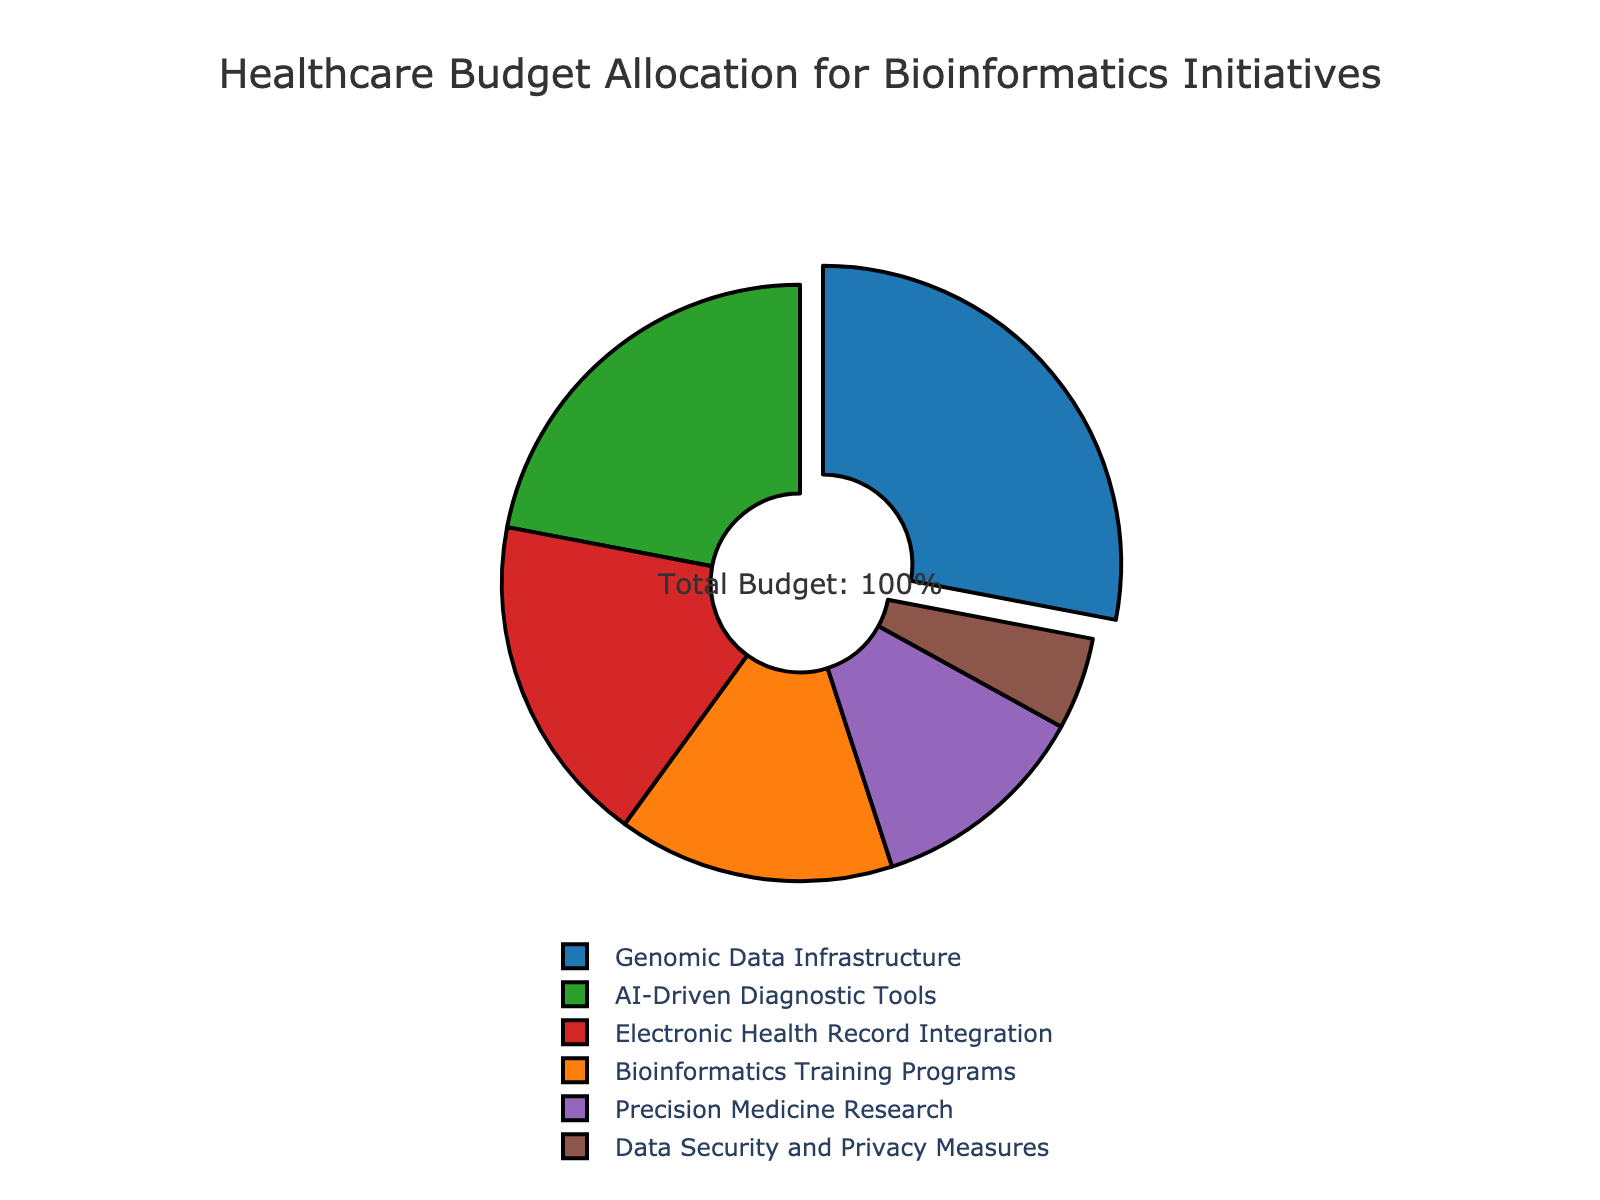What category has the highest budget allocation and what is its percentage? By looking at the pie chart, the section that is pulled out and has the highest percentage corresponds to the category "Genomic Data Infrastructure." The percentage labeled for this section is 28%.
Answer: Genomic Data Infrastructure, 28% Which category receives a budget allocation that is less than both AI-Driven Diagnostic Tools and Electronic Health Record Integration? To find this, we compare the percentages for AI-Driven Diagnostic Tools (22%) and Electronic Health Record Integration (18%). The category "Precision Medicine Research" has a budget allocation of 12%, which is less than both.
Answer: Precision Medicine Research What is the total budget allocation for categories related to data (Genomic Data Infrastructure, Data Security and Privacy Measures)? Sum the allocations of Genomic Data Infrastructure (28%) and Data Security and Privacy Measures (5%): 28 + 5 = 33%.
Answer: 33% Which category has the smallest budget allocation and how much is it? The smallest segment in the pie chart correlates to "Data Security and Privacy Measures," which has a 5% allocation.
Answer: Data Security and Privacy Measures, 5% How does the budget allocation for AI-Driven Diagnostic Tools compare to Bioinformatics Training Programs? By comparing the percentages, AI-Driven Diagnostic Tools has 22% while Bioinformatics Training Programs has 15%. AI-Driven Diagnostic Tools has a larger budget allocation.
Answer: AI-Driven Diagnostic Tools has a larger budget allocation What is the combined percentage allocation for AI-Driven Diagnostic Tools and Bioinformatics Training Programs? Adding the percentages together for AI-Driven Diagnostic Tools (22%) and Bioinformatics Training Programs (15%): 22 + 15 = 37%.
Answer: 37% Which category has a budget allocation just greater than Precision Medicine Research and what is its percentage? Precision Medicine Research is allocated 12%. The next higher allocation is for Electronic Health Record Integration with 18%.
Answer: Electronic Health Record Integration, 18% What is the difference in budget allocation between the highest and the lowest categories? Subtract the lowest allocation (5% for Data Security and Privacy Measures) from the highest allocation (28% for Genomic Data Infrastructure): 28 - 5 = 23%.
Answer: 23% 